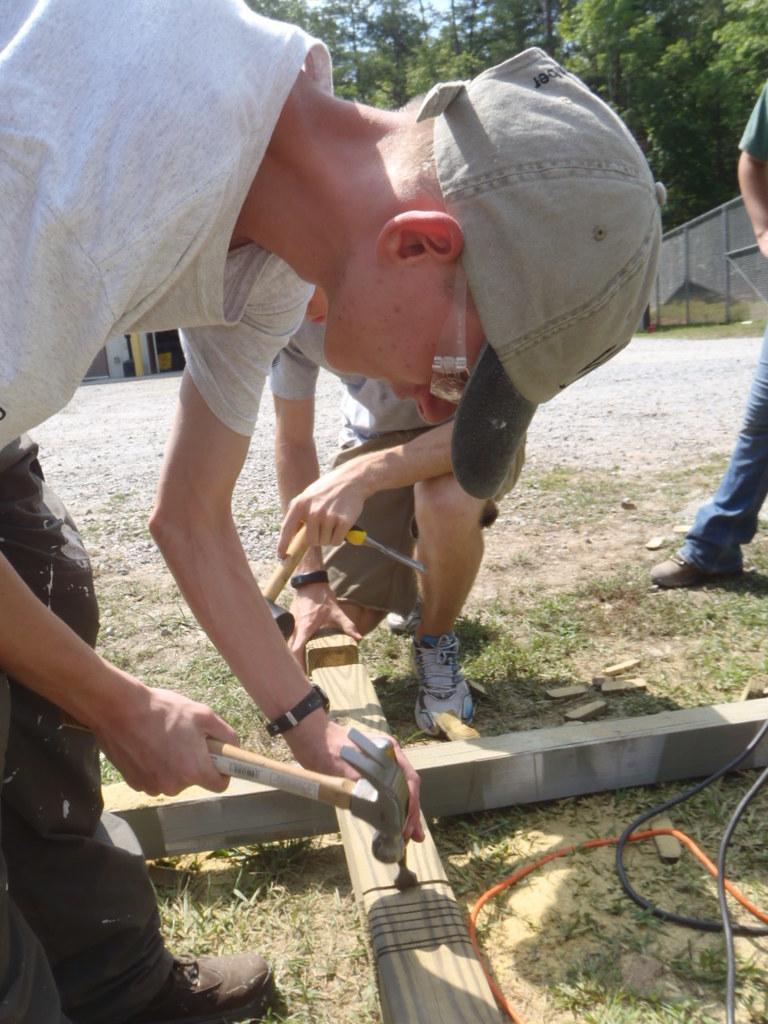How would you summarize this image in a sentence or two? In this picture we can see there are three persons and a man is holding a hammer. At the bottom right corner of the image, there are cables. Behind the people, there are trees, fencing and the sky. 